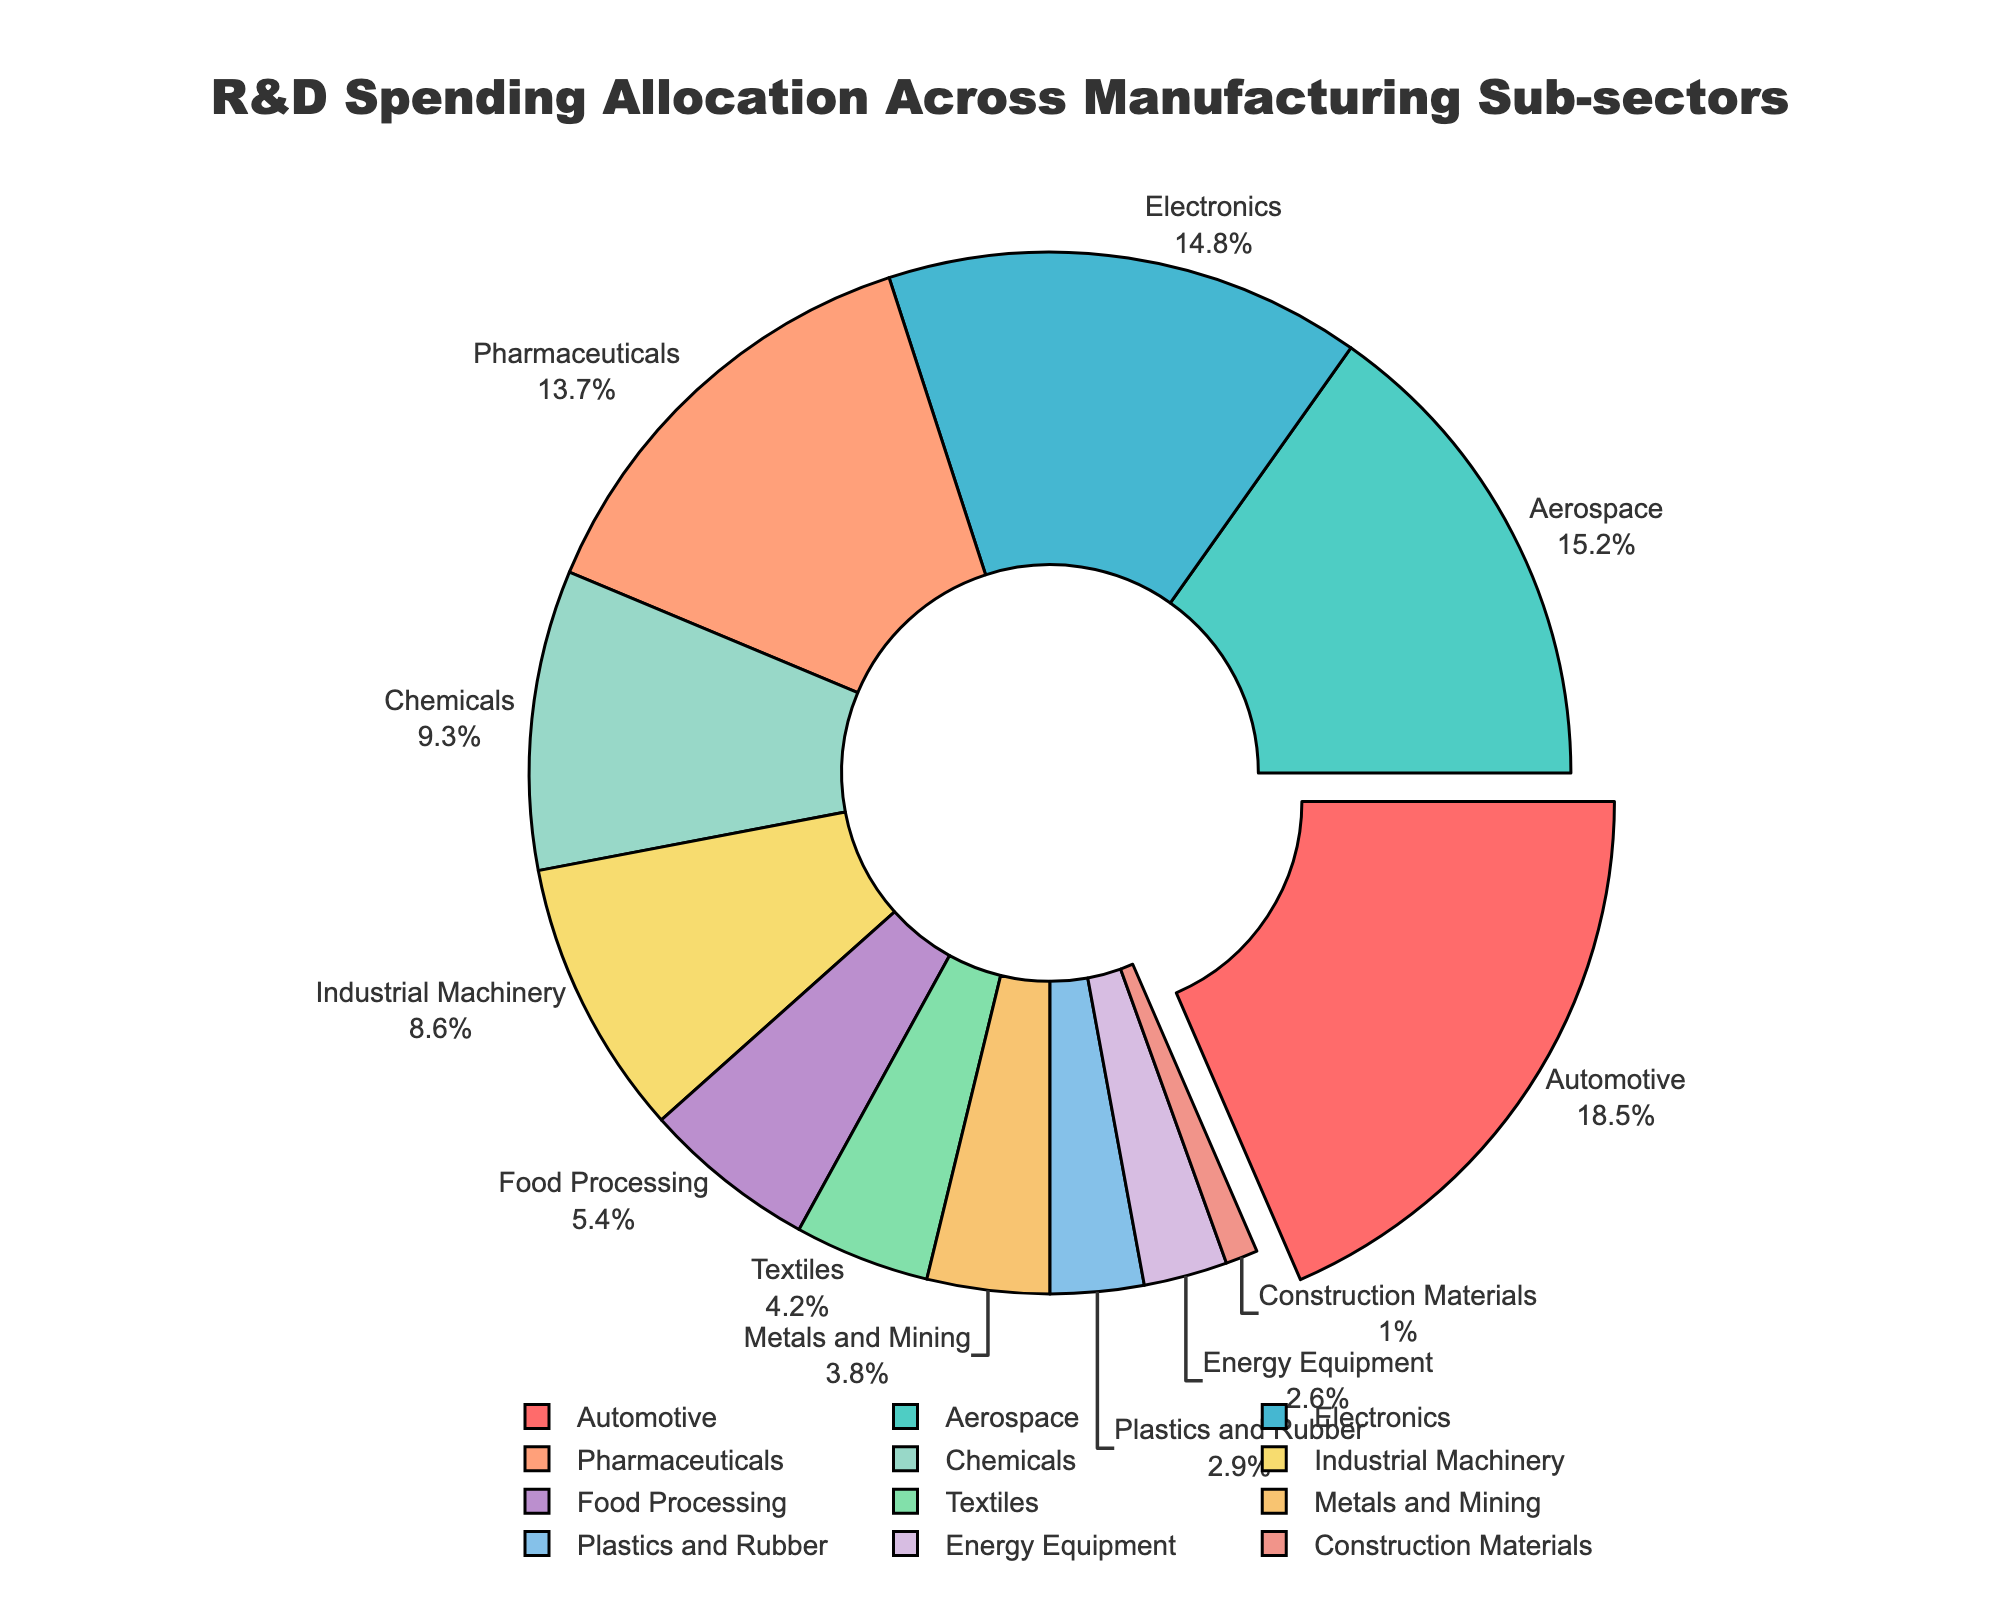Which manufacturing sub-sector has the highest allocation of R&D spending? The pie chart shows the different percentages of R&D spending for each sub-sector with the Automotive sector having the largest segment pulled out for emphasis. This indicates the highest allocation of R&D is in the Automotive sector at 18.5%.
Answer: Automotive Which two sub-sectors have the closest R&D spending allocations? From the pie chart, the Aerospace sector has 15.2% and the Electronics sector has 14.8%, which are the closest percentages in the chart.
Answer: Aerospace and Electronics What is the total R&D spending allocation percentage for the top three sub-sectors? The top three sub-sectors can be found by identifying the largest slices in the pie chart, which are Automotive (18.5%), Aerospace (15.2%), and Electronics (14.8%). The total is calculated as 18.5% + 15.2% + 14.8% = 48.5%.
Answer: 48.5% Which sub-sector has a lower R&D spending allocation: Pharmaceuticals or Chemicals? The pie chart shows that Pharmaceuticals has 13.7% and Chemicals has 9.3%. Since 9.3% is less than 13.7%, Chemicals has a lower R&D spending allocation.
Answer: Chemicals What is the difference in R&D spending allocation between the highest and lowest sub-sectors? The highest sub-sector is Automotive with 18.5%, and the lowest is Construction Materials with 1.0%. The difference is calculated as 18.5% - 1.0% = 17.5%.
Answer: 17.5% How many sub-sectors have R&D spending allocations above 10%? By examining the pie chart, we can count the sub-sectors with allocations above 10%. These are Automotive (18.5%), Aerospace (15.2%), Electronics (14.8%), and Pharmaceuticals (13.7%), totaling 4 sub-sectors.
Answer: 4 Is the allocation for Industrial Machinery greater than that for Food Processing? From the pie chart, Industrial Machinery has 8.6% and Food Processing has 5.4%. Since 8.6% is greater than 5.4%, Industrial Machinery has a greater allocation.
Answer: Yes What is the combined percentage of R&D spending allocation for sub-sectors related to primary materials (Metals and Mining, and Construction Materials)? The pie chart data shows Metals and Mining at 3.8% and Construction Materials at 1.0%. The combined allocation is 3.8% + 1.0% = 4.8%.
Answer: 4.8% How does the R&D spending allocation for Chemicals compare visually to that for Energy Equipment? By looking at the pie chart segments' sizes, Chemicals has a larger slice at 9.3% compared to the smaller slice of Energy Equipment at 2.6%. This visual comparison shows Chemicals has a noticeably larger allocation.
Answer: Chemicals has a larger allocation 